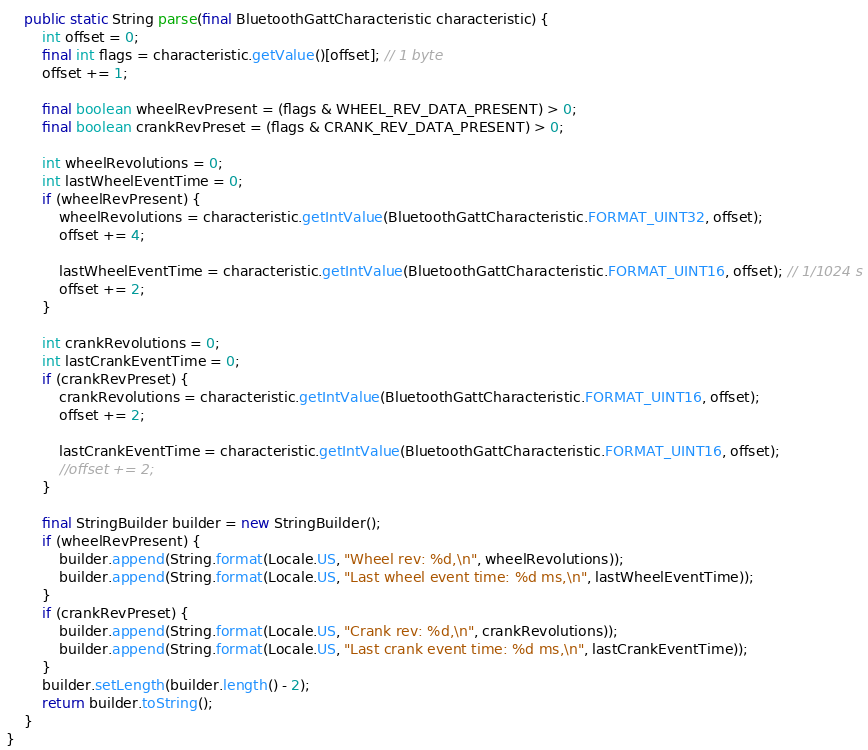<code> <loc_0><loc_0><loc_500><loc_500><_Java_>
	public static String parse(final BluetoothGattCharacteristic characteristic) {
		int offset = 0;
		final int flags = characteristic.getValue()[offset]; // 1 byte
		offset += 1;

		final boolean wheelRevPresent = (flags & WHEEL_REV_DATA_PRESENT) > 0;
		final boolean crankRevPreset = (flags & CRANK_REV_DATA_PRESENT) > 0;

		int wheelRevolutions = 0;
		int lastWheelEventTime = 0;
		if (wheelRevPresent) {
			wheelRevolutions = characteristic.getIntValue(BluetoothGattCharacteristic.FORMAT_UINT32, offset);
			offset += 4;

			lastWheelEventTime = characteristic.getIntValue(BluetoothGattCharacteristic.FORMAT_UINT16, offset); // 1/1024 s
			offset += 2;
		}

		int crankRevolutions = 0;
		int lastCrankEventTime = 0;
		if (crankRevPreset) {
			crankRevolutions = characteristic.getIntValue(BluetoothGattCharacteristic.FORMAT_UINT16, offset);
			offset += 2;

			lastCrankEventTime = characteristic.getIntValue(BluetoothGattCharacteristic.FORMAT_UINT16, offset);
			//offset += 2;
		}

		final StringBuilder builder = new StringBuilder();
		if (wheelRevPresent) {
			builder.append(String.format(Locale.US, "Wheel rev: %d,\n", wheelRevolutions));
			builder.append(String.format(Locale.US, "Last wheel event time: %d ms,\n", lastWheelEventTime));
		}
		if (crankRevPreset) {
			builder.append(String.format(Locale.US, "Crank rev: %d,\n", crankRevolutions));
			builder.append(String.format(Locale.US, "Last crank event time: %d ms,\n", lastCrankEventTime));
		}
		builder.setLength(builder.length() - 2);
		return builder.toString();
	}
}
</code> 